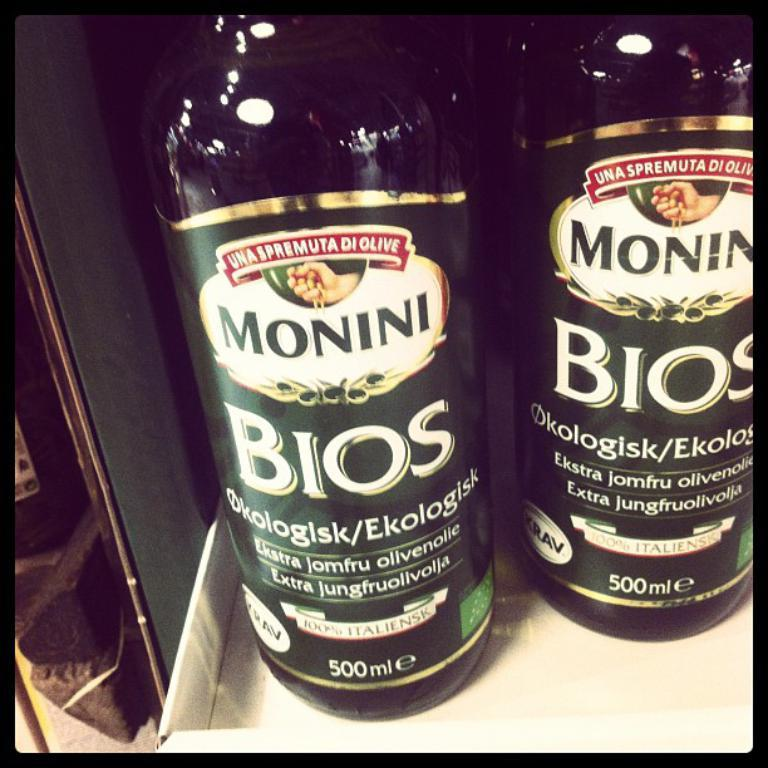Provide a one-sentence caption for the provided image. some bottles of Monini Bios 500 ML on a display shelf. 